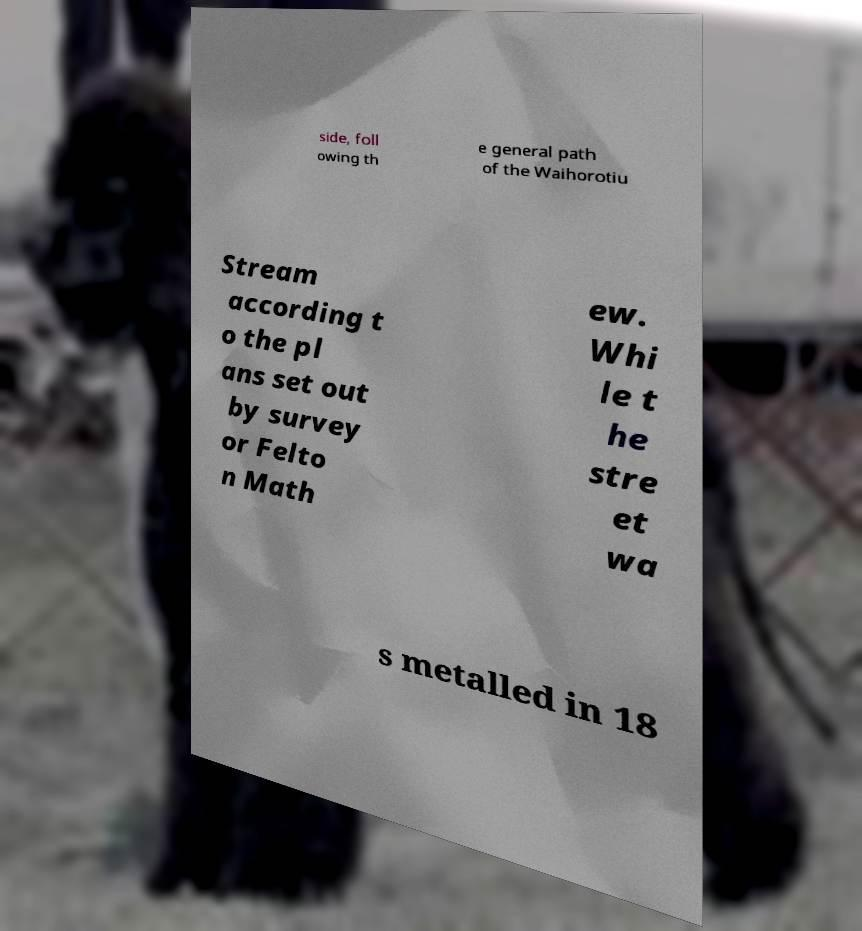Could you assist in decoding the text presented in this image and type it out clearly? side, foll owing th e general path of the Waihorotiu Stream according t o the pl ans set out by survey or Felto n Math ew. Whi le t he stre et wa s metalled in 18 